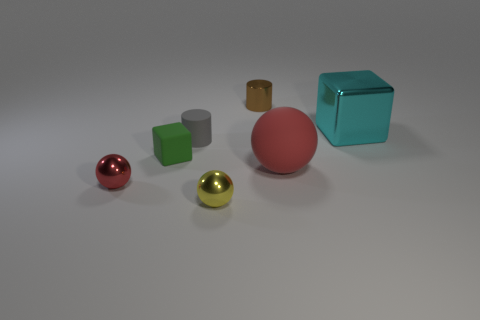If these objects were part of a still life painting, what mood might the artist be conveying? If these objects were featured in a still life painting, the artist could be conveying a mood of calmness and simplicity. The muted background and the orderly arrangement of objects with varying shapes and subtle colors might suggest a sense of harmony and balance. 